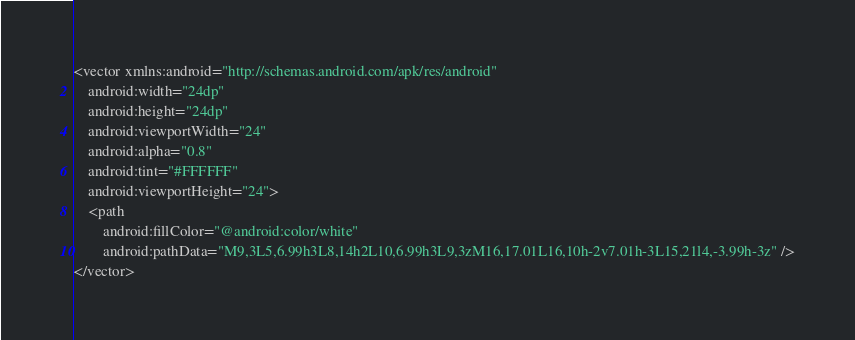<code> <loc_0><loc_0><loc_500><loc_500><_XML_><vector xmlns:android="http://schemas.android.com/apk/res/android"
    android:width="24dp"
    android:height="24dp"
    android:viewportWidth="24"
    android:alpha="0.8"
    android:tint="#FFFFFF"
    android:viewportHeight="24">
    <path
        android:fillColor="@android:color/white"
        android:pathData="M9,3L5,6.99h3L8,14h2L10,6.99h3L9,3zM16,17.01L16,10h-2v7.01h-3L15,21l4,-3.99h-3z" />
</vector>
</code> 